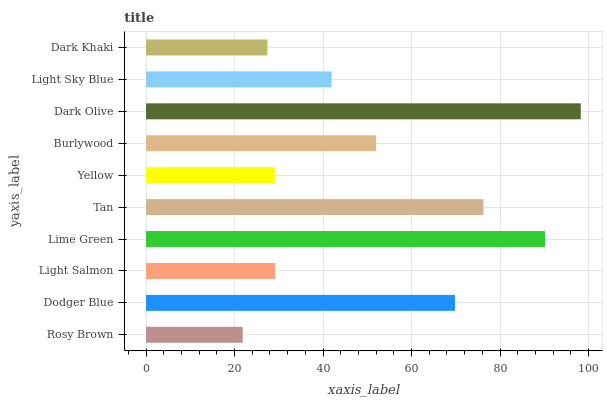Is Rosy Brown the minimum?
Answer yes or no. Yes. Is Dark Olive the maximum?
Answer yes or no. Yes. Is Dodger Blue the minimum?
Answer yes or no. No. Is Dodger Blue the maximum?
Answer yes or no. No. Is Dodger Blue greater than Rosy Brown?
Answer yes or no. Yes. Is Rosy Brown less than Dodger Blue?
Answer yes or no. Yes. Is Rosy Brown greater than Dodger Blue?
Answer yes or no. No. Is Dodger Blue less than Rosy Brown?
Answer yes or no. No. Is Burlywood the high median?
Answer yes or no. Yes. Is Light Sky Blue the low median?
Answer yes or no. Yes. Is Light Sky Blue the high median?
Answer yes or no. No. Is Yellow the low median?
Answer yes or no. No. 